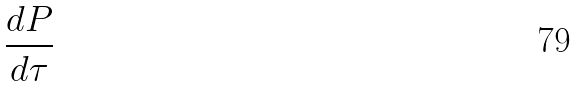<formula> <loc_0><loc_0><loc_500><loc_500>\frac { d P } { d \tau }</formula> 